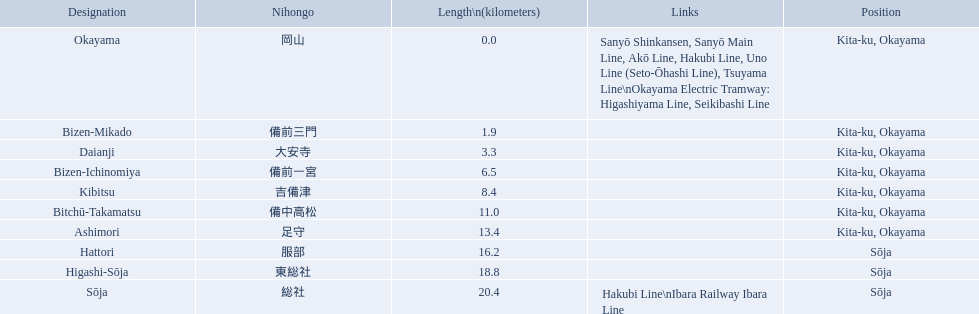What are all the stations on the kibi line? Okayama, Bizen-Mikado, Daianji, Bizen-Ichinomiya, Kibitsu, Bitchū-Takamatsu, Ashimori, Hattori, Higashi-Sōja, Sōja. What are the distances of these stations from the start of the line? 0.0, 1.9, 3.3, 6.5, 8.4, 11.0, 13.4, 16.2, 18.8, 20.4. Of these, which is larger than 1 km? 1.9, 3.3, 6.5, 8.4, 11.0, 13.4, 16.2, 18.8, 20.4. Of these, which is smaller than 2 km? 1.9. Which station is this distance from the start of the line? Bizen-Mikado. What are the members of the kibi line? Okayama, Bizen-Mikado, Daianji, Bizen-Ichinomiya, Kibitsu, Bitchū-Takamatsu, Ashimori, Hattori, Higashi-Sōja, Sōja. Which of them have a distance of more than 1 km? Bizen-Mikado, Daianji, Bizen-Ichinomiya, Kibitsu, Bitchū-Takamatsu, Ashimori, Hattori, Higashi-Sōja, Sōja. Which of them have a distance of less than 2 km? Okayama, Bizen-Mikado. Which has a distance between 1 km and 2 km? Bizen-Mikado. 